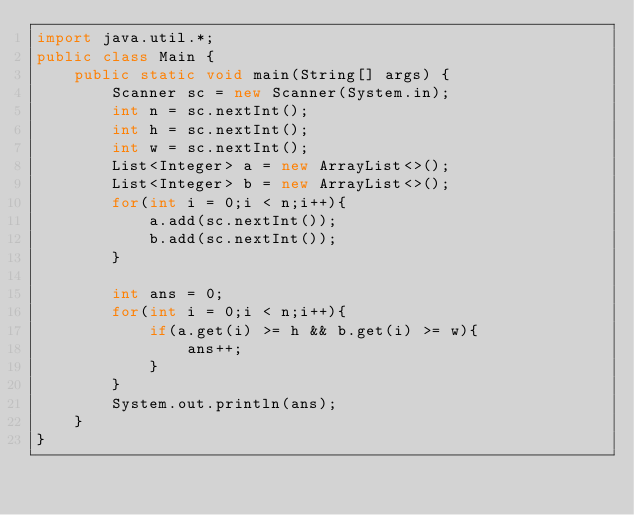Convert code to text. <code><loc_0><loc_0><loc_500><loc_500><_Java_>import java.util.*;
public class Main {
    public static void main(String[] args) {
        Scanner sc = new Scanner(System.in);
        int n = sc.nextInt();
        int h = sc.nextInt();
        int w = sc.nextInt();
        List<Integer> a = new ArrayList<>();
        List<Integer> b = new ArrayList<>();
        for(int i = 0;i < n;i++){
            a.add(sc.nextInt());
            b.add(sc.nextInt());
        }

        int ans = 0;
        for(int i = 0;i < n;i++){
            if(a.get(i) >= h && b.get(i) >= w){
                ans++;
            }
        }
        System.out.println(ans);
    }
}
</code> 